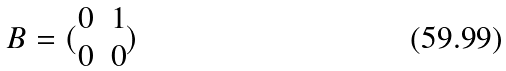<formula> <loc_0><loc_0><loc_500><loc_500>B = ( \begin{matrix} 0 & 1 \\ 0 & 0 \end{matrix} )</formula> 